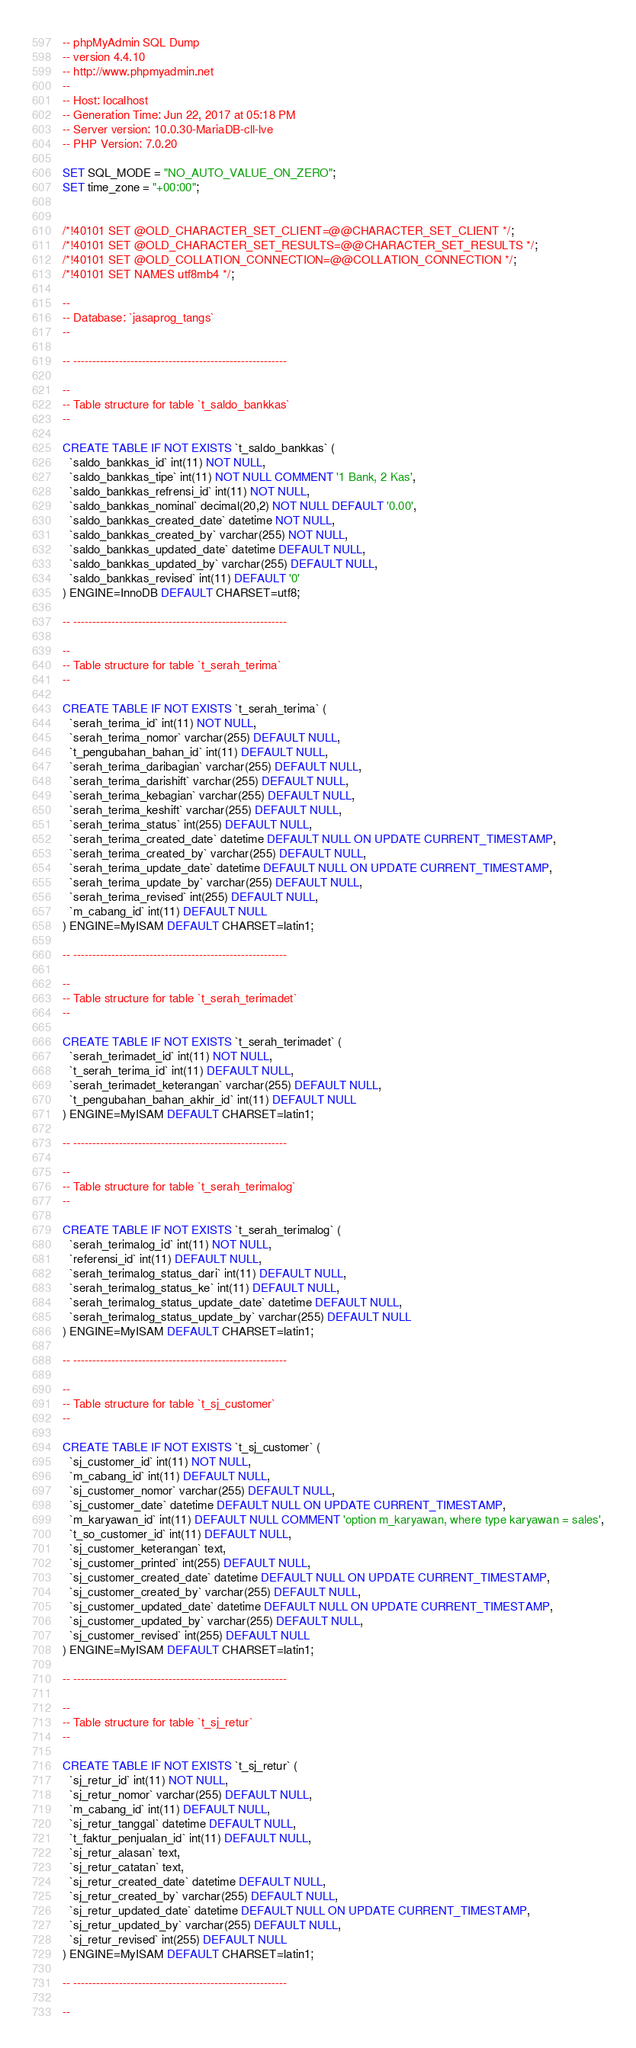Convert code to text. <code><loc_0><loc_0><loc_500><loc_500><_SQL_>-- phpMyAdmin SQL Dump
-- version 4.4.10
-- http://www.phpmyadmin.net
--
-- Host: localhost
-- Generation Time: Jun 22, 2017 at 05:18 PM
-- Server version: 10.0.30-MariaDB-cll-lve
-- PHP Version: 7.0.20

SET SQL_MODE = "NO_AUTO_VALUE_ON_ZERO";
SET time_zone = "+00:00";


/*!40101 SET @OLD_CHARACTER_SET_CLIENT=@@CHARACTER_SET_CLIENT */;
/*!40101 SET @OLD_CHARACTER_SET_RESULTS=@@CHARACTER_SET_RESULTS */;
/*!40101 SET @OLD_COLLATION_CONNECTION=@@COLLATION_CONNECTION */;
/*!40101 SET NAMES utf8mb4 */;

--
-- Database: `jasaprog_tangs`
--

-- --------------------------------------------------------

--
-- Table structure for table `t_saldo_bankkas`
--

CREATE TABLE IF NOT EXISTS `t_saldo_bankkas` (
  `saldo_bankkas_id` int(11) NOT NULL,
  `saldo_bankkas_tipe` int(11) NOT NULL COMMENT '1 Bank, 2 Kas',
  `saldo_bankkas_refrensi_id` int(11) NOT NULL,
  `saldo_bankkas_nominal` decimal(20,2) NOT NULL DEFAULT '0.00',
  `saldo_bankkas_created_date` datetime NOT NULL,
  `saldo_bankkas_created_by` varchar(255) NOT NULL,
  `saldo_bankkas_updated_date` datetime DEFAULT NULL,
  `saldo_bankkas_updated_by` varchar(255) DEFAULT NULL,
  `saldo_bankkas_revised` int(11) DEFAULT '0'
) ENGINE=InnoDB DEFAULT CHARSET=utf8;

-- --------------------------------------------------------

--
-- Table structure for table `t_serah_terima`
--

CREATE TABLE IF NOT EXISTS `t_serah_terima` (
  `serah_terima_id` int(11) NOT NULL,
  `serah_terima_nomor` varchar(255) DEFAULT NULL,
  `t_pengubahan_bahan_id` int(11) DEFAULT NULL,
  `serah_terima_daribagian` varchar(255) DEFAULT NULL,
  `serah_terima_darishift` varchar(255) DEFAULT NULL,
  `serah_terima_kebagian` varchar(255) DEFAULT NULL,
  `serah_terima_keshift` varchar(255) DEFAULT NULL,
  `serah_terima_status` int(255) DEFAULT NULL,
  `serah_terima_created_date` datetime DEFAULT NULL ON UPDATE CURRENT_TIMESTAMP,
  `serah_terima_created_by` varchar(255) DEFAULT NULL,
  `serah_terima_update_date` datetime DEFAULT NULL ON UPDATE CURRENT_TIMESTAMP,
  `serah_terima_update_by` varchar(255) DEFAULT NULL,
  `serah_terima_revised` int(255) DEFAULT NULL,
  `m_cabang_id` int(11) DEFAULT NULL
) ENGINE=MyISAM DEFAULT CHARSET=latin1;

-- --------------------------------------------------------

--
-- Table structure for table `t_serah_terimadet`
--

CREATE TABLE IF NOT EXISTS `t_serah_terimadet` (
  `serah_terimadet_id` int(11) NOT NULL,
  `t_serah_terima_id` int(11) DEFAULT NULL,
  `serah_terimadet_keterangan` varchar(255) DEFAULT NULL,
  `t_pengubahan_bahan_akhir_id` int(11) DEFAULT NULL
) ENGINE=MyISAM DEFAULT CHARSET=latin1;

-- --------------------------------------------------------

--
-- Table structure for table `t_serah_terimalog`
--

CREATE TABLE IF NOT EXISTS `t_serah_terimalog` (
  `serah_terimalog_id` int(11) NOT NULL,
  `referensi_id` int(11) DEFAULT NULL,
  `serah_terimalog_status_dari` int(11) DEFAULT NULL,
  `serah_terimalog_status_ke` int(11) DEFAULT NULL,
  `serah_terimalog_status_update_date` datetime DEFAULT NULL,
  `serah_terimalog_status_update_by` varchar(255) DEFAULT NULL
) ENGINE=MyISAM DEFAULT CHARSET=latin1;

-- --------------------------------------------------------

--
-- Table structure for table `t_sj_customer`
--

CREATE TABLE IF NOT EXISTS `t_sj_customer` (
  `sj_customer_id` int(11) NOT NULL,
  `m_cabang_id` int(11) DEFAULT NULL,
  `sj_customer_nomor` varchar(255) DEFAULT NULL,
  `sj_customer_date` datetime DEFAULT NULL ON UPDATE CURRENT_TIMESTAMP,
  `m_karyawan_id` int(11) DEFAULT NULL COMMENT 'option m_karyawan, where type karyawan = sales',
  `t_so_customer_id` int(11) DEFAULT NULL,
  `sj_customer_keterangan` text,
  `sj_customer_printed` int(255) DEFAULT NULL,
  `sj_customer_created_date` datetime DEFAULT NULL ON UPDATE CURRENT_TIMESTAMP,
  `sj_customer_created_by` varchar(255) DEFAULT NULL,
  `sj_customer_updated_date` datetime DEFAULT NULL ON UPDATE CURRENT_TIMESTAMP,
  `sj_customer_updated_by` varchar(255) DEFAULT NULL,
  `sj_customer_revised` int(255) DEFAULT NULL
) ENGINE=MyISAM DEFAULT CHARSET=latin1;

-- --------------------------------------------------------

--
-- Table structure for table `t_sj_retur`
--

CREATE TABLE IF NOT EXISTS `t_sj_retur` (
  `sj_retur_id` int(11) NOT NULL,
  `sj_retur_nomor` varchar(255) DEFAULT NULL,
  `m_cabang_id` int(11) DEFAULT NULL,
  `sj_retur_tanggal` datetime DEFAULT NULL,
  `t_faktur_penjualan_id` int(11) DEFAULT NULL,
  `sj_retur_alasan` text,
  `sj_retur_catatan` text,
  `sj_retur_created_date` datetime DEFAULT NULL,
  `sj_retur_created_by` varchar(255) DEFAULT NULL,
  `sj_retur_updated_date` datetime DEFAULT NULL ON UPDATE CURRENT_TIMESTAMP,
  `sj_retur_updated_by` varchar(255) DEFAULT NULL,
  `sj_retur_revised` int(255) DEFAULT NULL
) ENGINE=MyISAM DEFAULT CHARSET=latin1;

-- --------------------------------------------------------

--</code> 